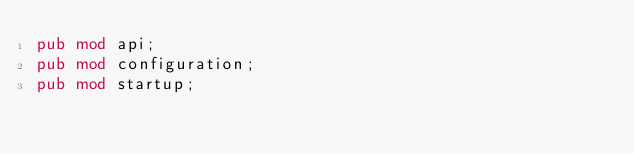<code> <loc_0><loc_0><loc_500><loc_500><_Rust_>pub mod api;
pub mod configuration;
pub mod startup;
</code> 